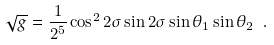<formula> <loc_0><loc_0><loc_500><loc_500>\sqrt { g } = \frac { 1 } { 2 ^ { 5 } } \cos ^ { 2 } { 2 { \sigma } } \sin { 2 { \sigma } } \sin { { \theta } _ { 1 } } \sin { { \theta } _ { 2 } } \ .</formula> 